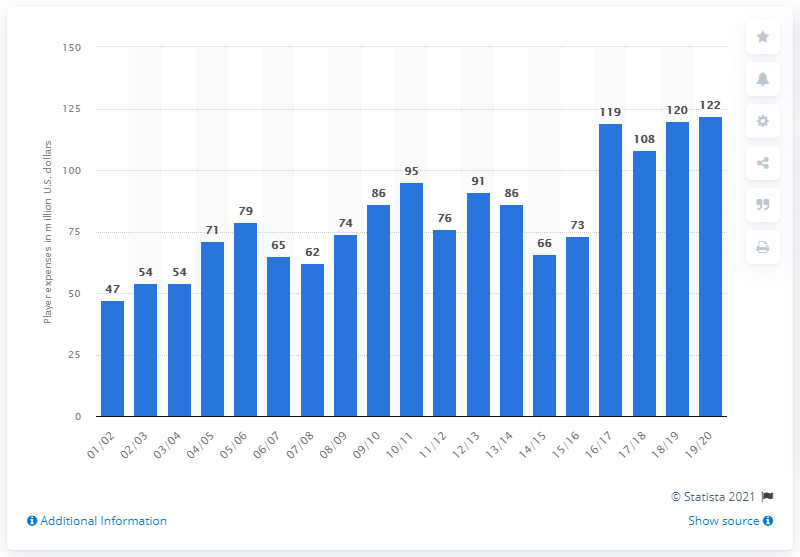Specify some key components in this picture. In the 2019/20 season, the Orlando Magic's player salaries totaled 122. 